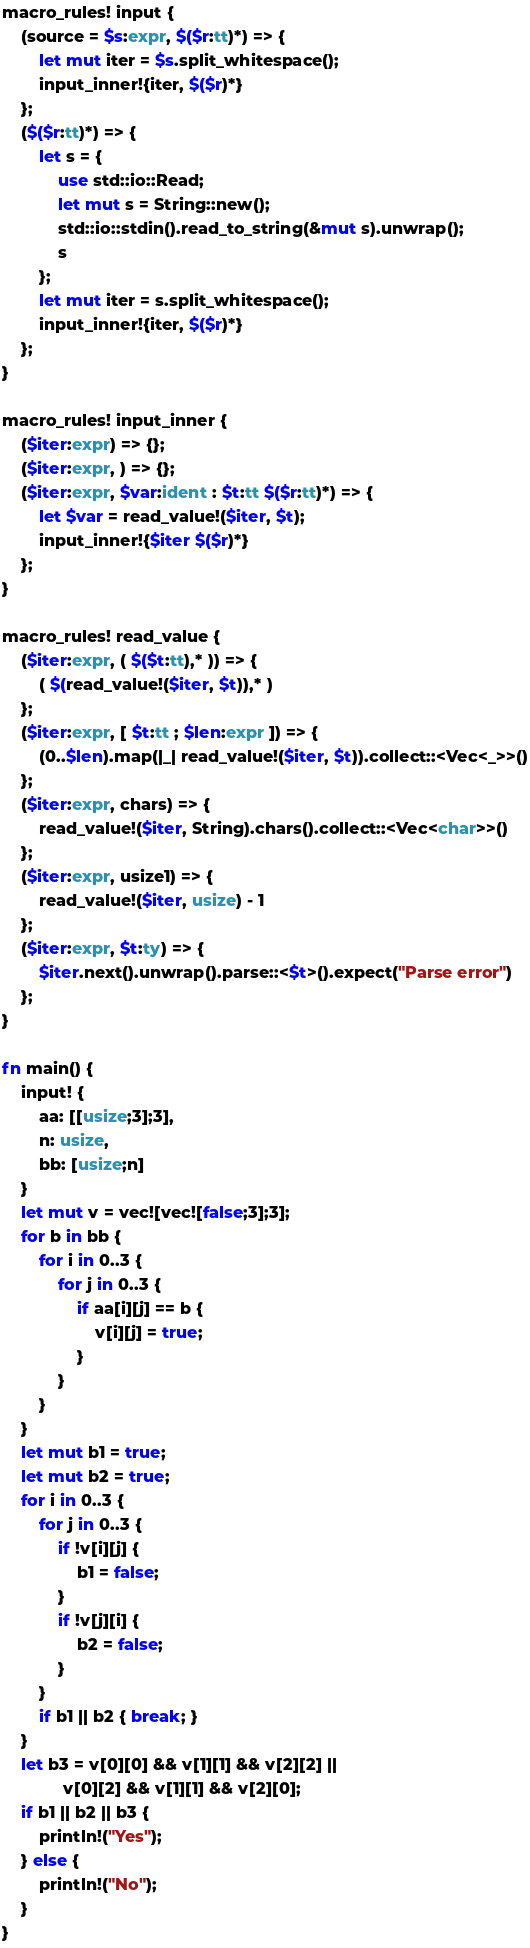<code> <loc_0><loc_0><loc_500><loc_500><_Rust_>macro_rules! input {
    (source = $s:expr, $($r:tt)*) => {
        let mut iter = $s.split_whitespace();
        input_inner!{iter, $($r)*}
    };
    ($($r:tt)*) => {
        let s = {
            use std::io::Read;
            let mut s = String::new();
            std::io::stdin().read_to_string(&mut s).unwrap();
            s
        };
        let mut iter = s.split_whitespace();
        input_inner!{iter, $($r)*}
    };
}

macro_rules! input_inner {
    ($iter:expr) => {};
    ($iter:expr, ) => {};
    ($iter:expr, $var:ident : $t:tt $($r:tt)*) => {
        let $var = read_value!($iter, $t);
        input_inner!{$iter $($r)*}
    };
}

macro_rules! read_value {
    ($iter:expr, ( $($t:tt),* )) => {
        ( $(read_value!($iter, $t)),* )
    };
    ($iter:expr, [ $t:tt ; $len:expr ]) => {
        (0..$len).map(|_| read_value!($iter, $t)).collect::<Vec<_>>()
    };
    ($iter:expr, chars) => {
        read_value!($iter, String).chars().collect::<Vec<char>>()
    };
    ($iter:expr, usize1) => {
        read_value!($iter, usize) - 1
    };
    ($iter:expr, $t:ty) => {
        $iter.next().unwrap().parse::<$t>().expect("Parse error")
    };
}

fn main() {
    input! {
        aa: [[usize;3];3],
        n: usize,
        bb: [usize;n]
    }
    let mut v = vec![vec![false;3];3];
    for b in bb {
        for i in 0..3 {
            for j in 0..3 {
                if aa[i][j] == b {
                    v[i][j] = true;
                }
            }
        }
    }
    let mut b1 = true;
    let mut b2 = true;
    for i in 0..3 {
        for j in 0..3 {
            if !v[i][j] {
                b1 = false;
            }
            if !v[j][i] {
                b2 = false;
            }
        }
        if b1 || b2 { break; }
    }
    let b3 = v[0][0] && v[1][1] && v[2][2] ||
             v[0][2] && v[1][1] && v[2][0];
    if b1 || b2 || b3 {
        println!("Yes");
    } else {
        println!("No");
    }
}
</code> 